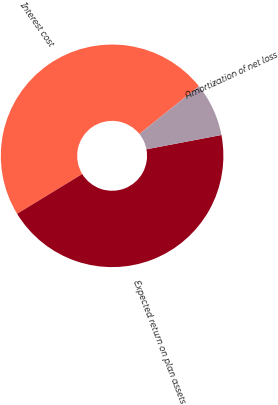Convert chart. <chart><loc_0><loc_0><loc_500><loc_500><pie_chart><fcel>Interest cost<fcel>Expected return on plan assets<fcel>Amortization of net loss<nl><fcel>47.97%<fcel>44.28%<fcel>7.76%<nl></chart> 